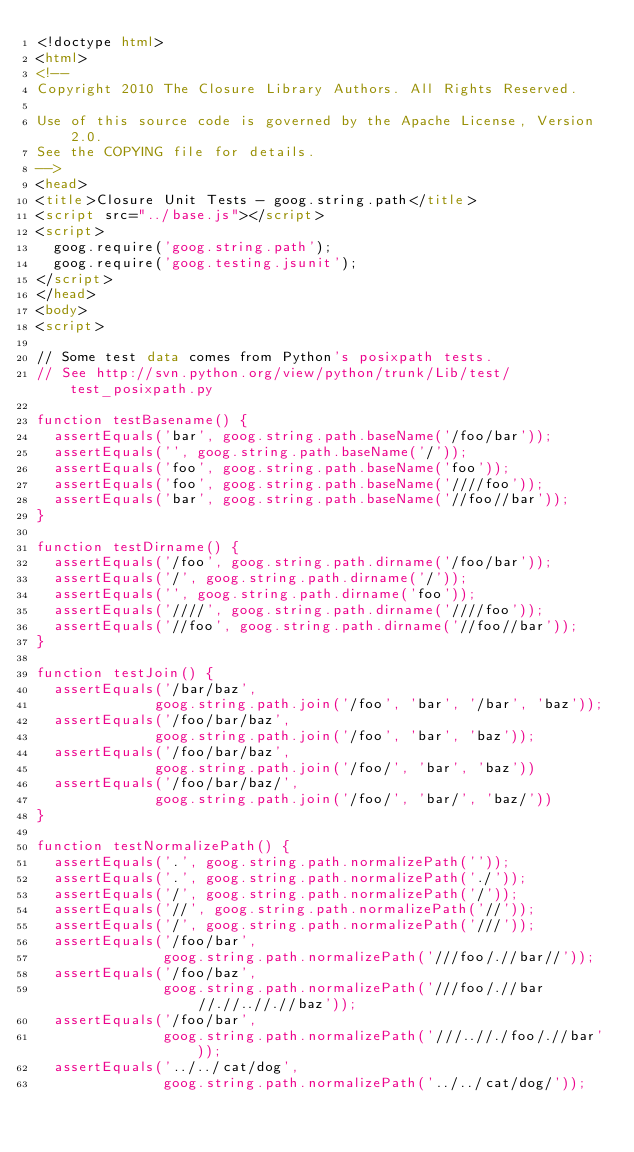<code> <loc_0><loc_0><loc_500><loc_500><_HTML_><!doctype html>
<html>
<!--
Copyright 2010 The Closure Library Authors. All Rights Reserved.

Use of this source code is governed by the Apache License, Version 2.0.
See the COPYING file for details.
-->
<head>
<title>Closure Unit Tests - goog.string.path</title>
<script src="../base.js"></script>
<script>
  goog.require('goog.string.path');
  goog.require('goog.testing.jsunit');
</script>
</head>
<body>
<script>

// Some test data comes from Python's posixpath tests.
// See http://svn.python.org/view/python/trunk/Lib/test/test_posixpath.py

function testBasename() {
  assertEquals('bar', goog.string.path.baseName('/foo/bar'));
  assertEquals('', goog.string.path.baseName('/'));
  assertEquals('foo', goog.string.path.baseName('foo'));
  assertEquals('foo', goog.string.path.baseName('////foo'));
  assertEquals('bar', goog.string.path.baseName('//foo//bar'));
}

function testDirname() {
  assertEquals('/foo', goog.string.path.dirname('/foo/bar'));
  assertEquals('/', goog.string.path.dirname('/'));
  assertEquals('', goog.string.path.dirname('foo'));
  assertEquals('////', goog.string.path.dirname('////foo'));
  assertEquals('//foo', goog.string.path.dirname('//foo//bar'));
}

function testJoin() {
  assertEquals('/bar/baz',
              goog.string.path.join('/foo', 'bar', '/bar', 'baz'));
  assertEquals('/foo/bar/baz',
              goog.string.path.join('/foo', 'bar', 'baz'));
  assertEquals('/foo/bar/baz',
              goog.string.path.join('/foo/', 'bar', 'baz'))
  assertEquals('/foo/bar/baz/',
              goog.string.path.join('/foo/', 'bar/', 'baz/'))
}

function testNormalizePath() {
  assertEquals('.', goog.string.path.normalizePath(''));
  assertEquals('.', goog.string.path.normalizePath('./'));
  assertEquals('/', goog.string.path.normalizePath('/'));
  assertEquals('//', goog.string.path.normalizePath('//'));
  assertEquals('/', goog.string.path.normalizePath('///'));
  assertEquals('/foo/bar',
               goog.string.path.normalizePath('///foo/.//bar//'));
  assertEquals('/foo/baz',
               goog.string.path.normalizePath('///foo/.//bar//.//..//.//baz'));
  assertEquals('/foo/bar',
               goog.string.path.normalizePath('///..//./foo/.//bar'));
  assertEquals('../../cat/dog',
               goog.string.path.normalizePath('../../cat/dog/'));</code> 